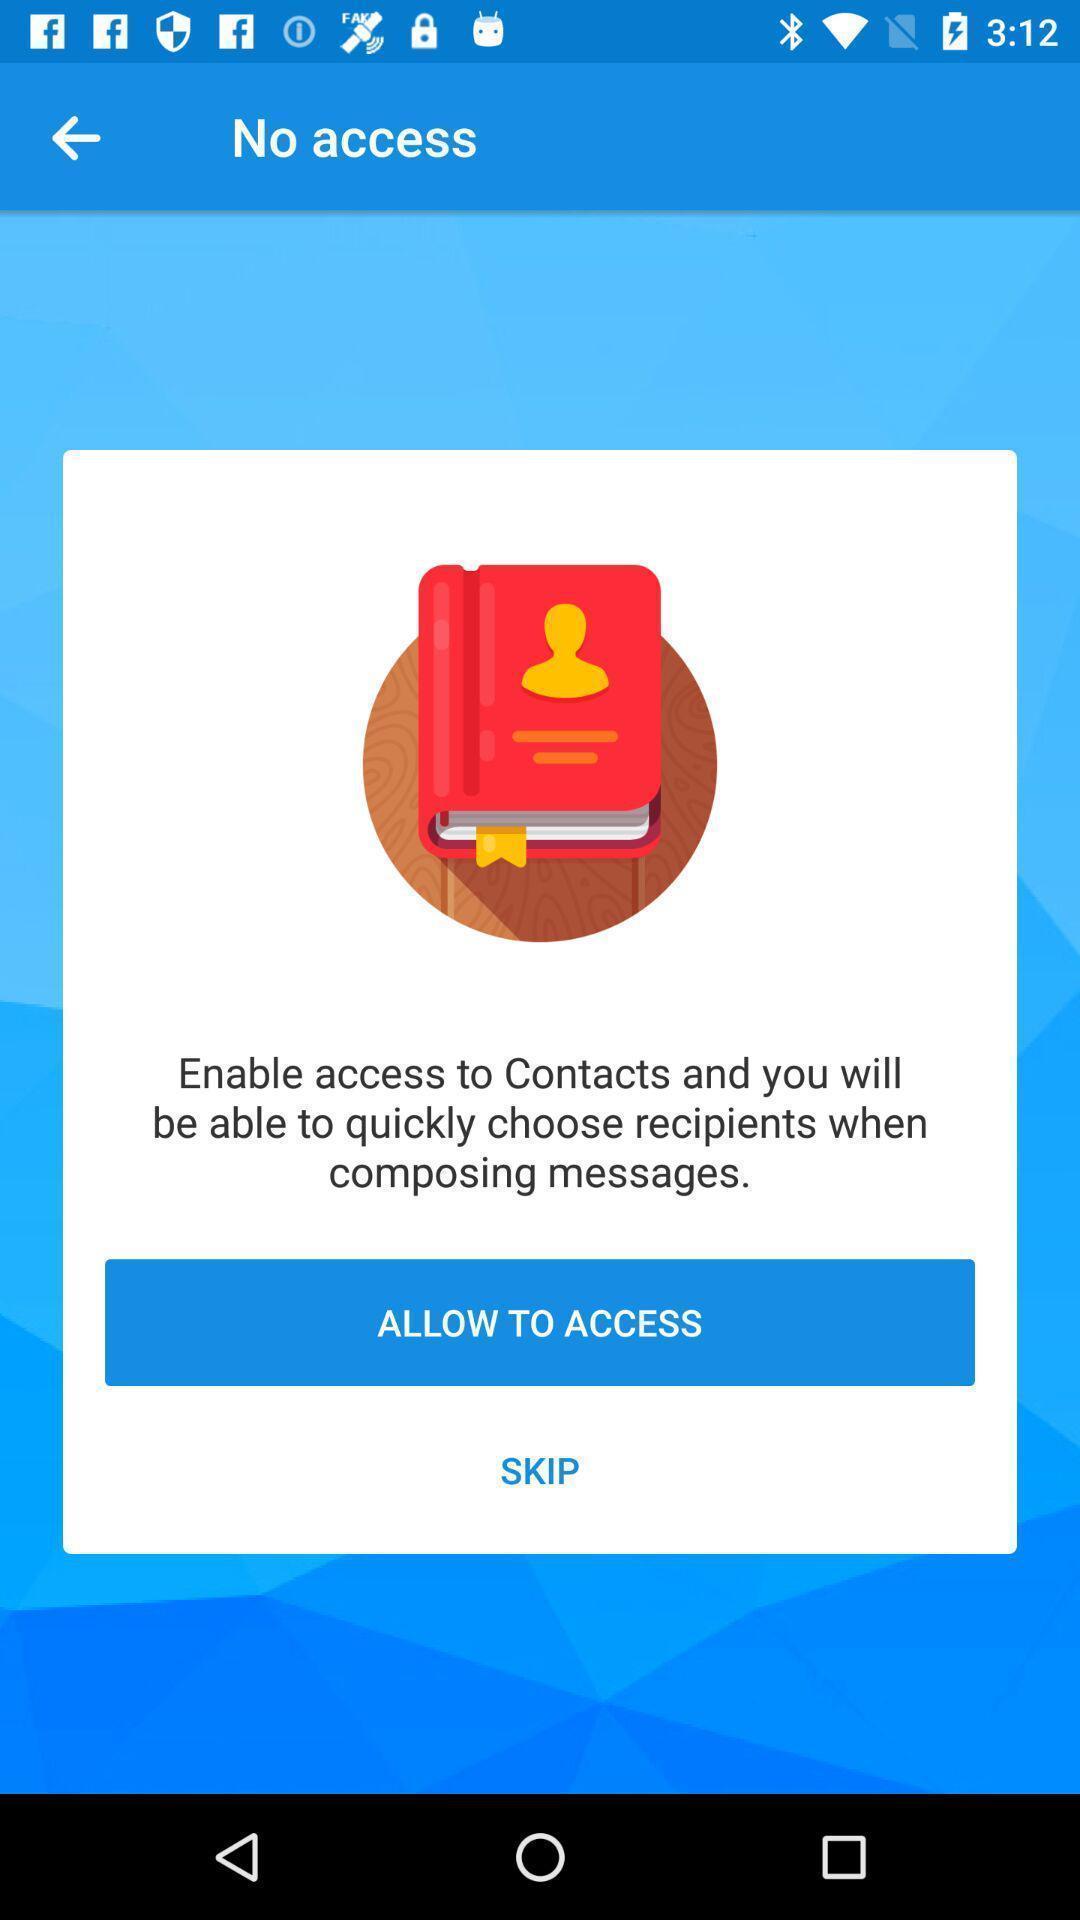What can you discern from this picture? Pop-up showing some information in an social applications. 